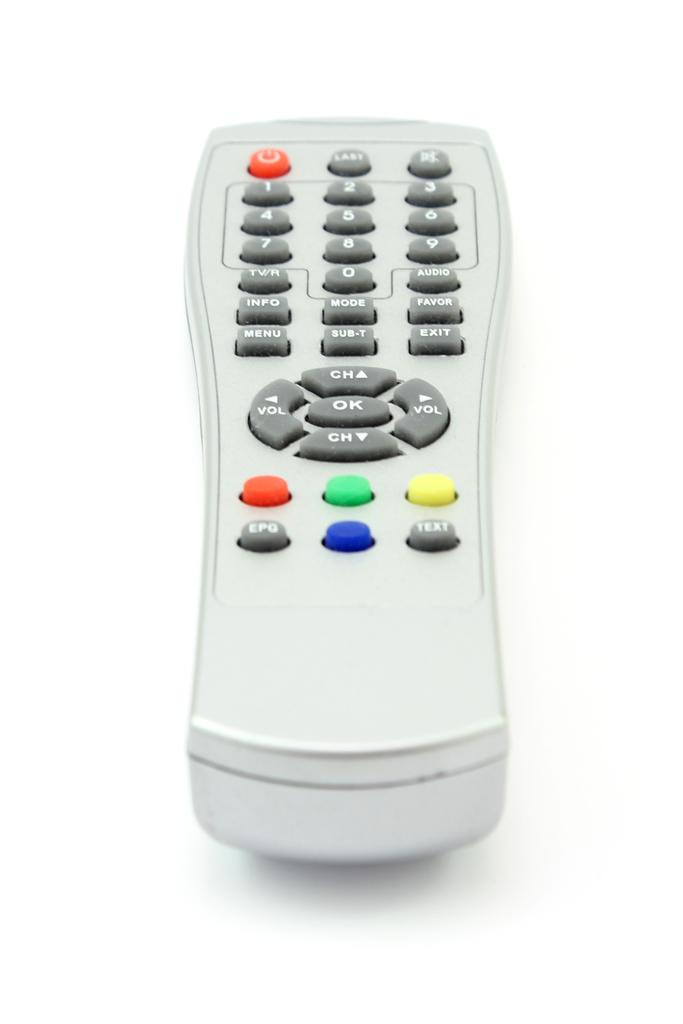<image>
Render a clear and concise summary of the photo. Gray remote controller with the text button on the bottom right. 